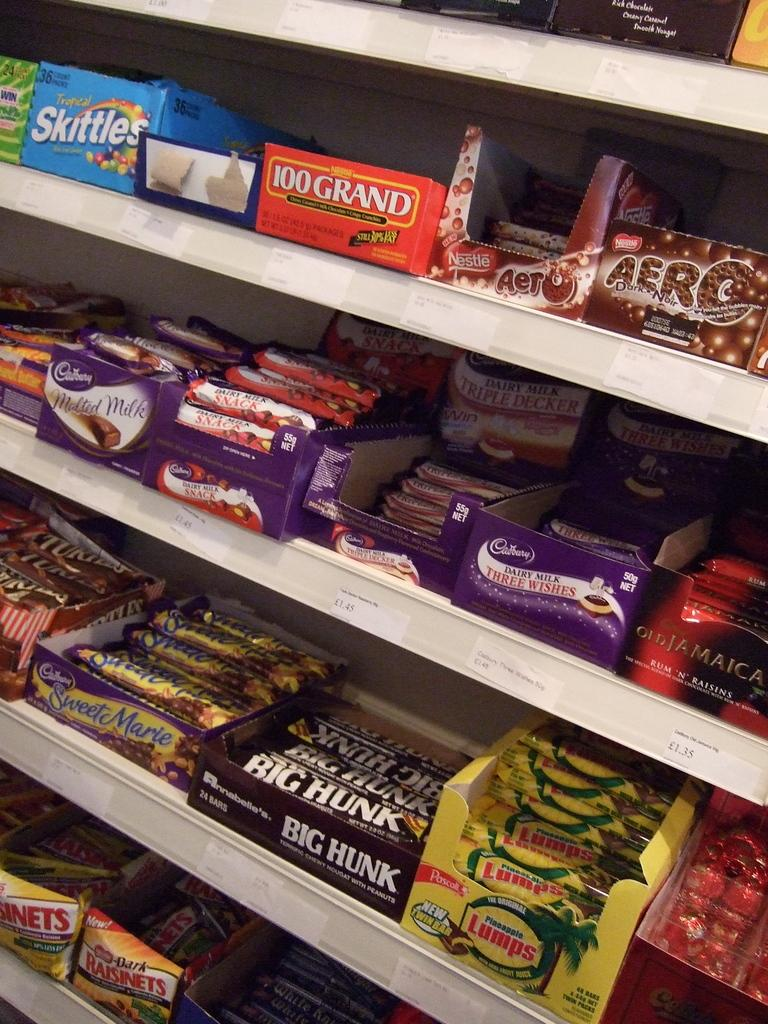What type of food is visible in the image? There are chocolates in the image. How are the chocolates packaged? The chocolates are in cardboard boxes. Where are the cardboard boxes with chocolates located? The cardboard boxes with chocolates are on a white-colored rack. How does the calendar help in connecting the chocolates in the image? There is no calendar present in the image, and therefore no connection can be established between the chocolates and a calendar. 